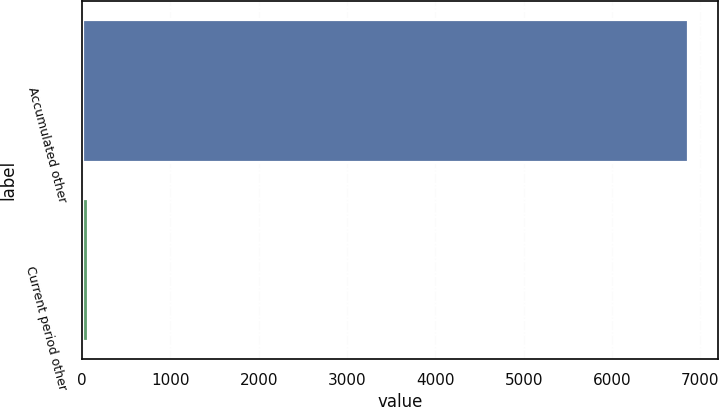Convert chart to OTSL. <chart><loc_0><loc_0><loc_500><loc_500><bar_chart><fcel>Accumulated other<fcel>Current period other<nl><fcel>6855<fcel>65<nl></chart> 